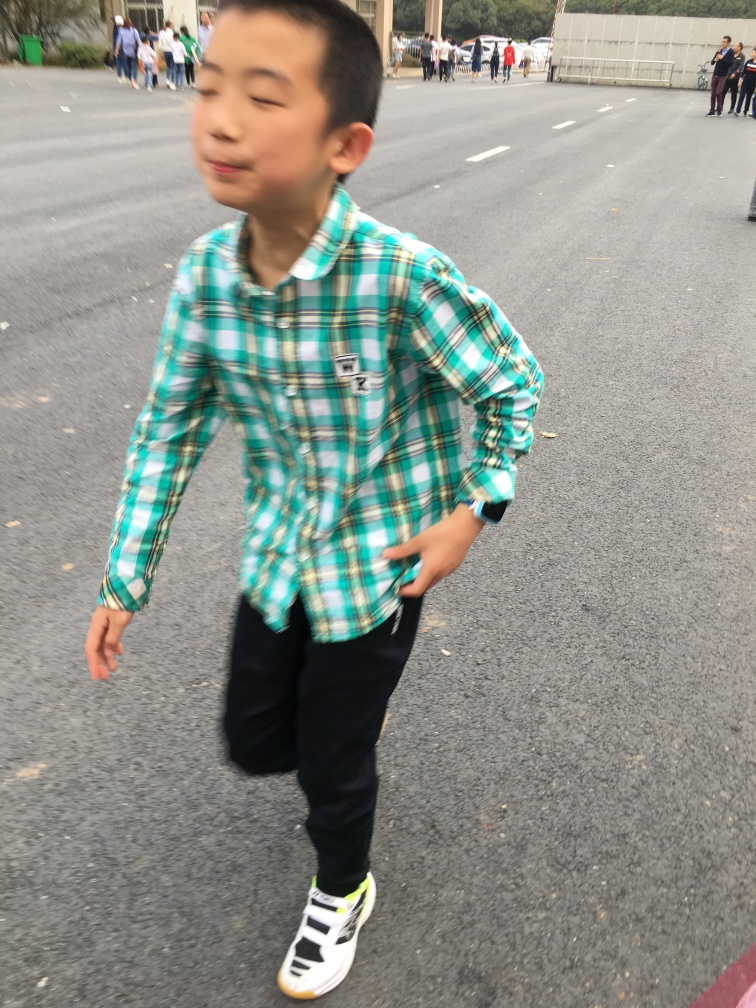Can you describe the setting around the person? The setting appears to be an outdoor urban space, with various indistinct figures and cars in the background. The presence of a crowd and the wide, open pavement suggest the vicinity could be near an event or public gathering area. 